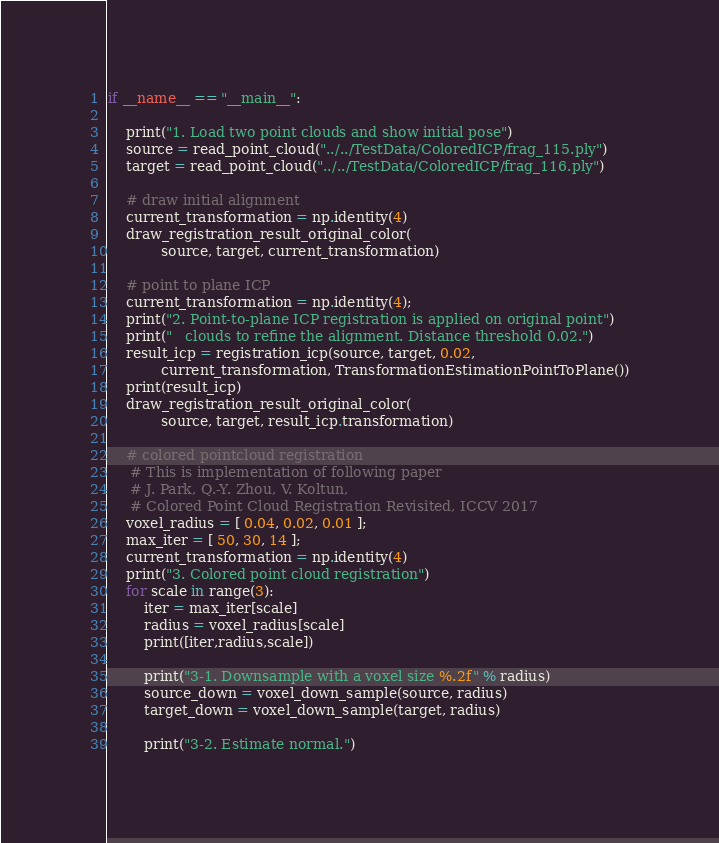<code> <loc_0><loc_0><loc_500><loc_500><_Python_>
if __name__ == "__main__":

    print("1. Load two point clouds and show initial pose")
    source = read_point_cloud("../../TestData/ColoredICP/frag_115.ply")
    target = read_point_cloud("../../TestData/ColoredICP/frag_116.ply")

    # draw initial alignment
    current_transformation = np.identity(4)
    draw_registration_result_original_color(
            source, target, current_transformation)

    # point to plane ICP
    current_transformation = np.identity(4);
    print("2. Point-to-plane ICP registration is applied on original point")
    print("   clouds to refine the alignment. Distance threshold 0.02.")
    result_icp = registration_icp(source, target, 0.02,
            current_transformation, TransformationEstimationPointToPlane())
    print(result_icp)
    draw_registration_result_original_color(
            source, target, result_icp.transformation)

    # colored pointcloud registration
     # This is implementation of following paper
     # J. Park, Q.-Y. Zhou, V. Koltun,
     # Colored Point Cloud Registration Revisited, ICCV 2017
    voxel_radius = [ 0.04, 0.02, 0.01 ];
    max_iter = [ 50, 30, 14 ];
    current_transformation = np.identity(4)
    print("3. Colored point cloud registration")
    for scale in range(3):
        iter = max_iter[scale]
        radius = voxel_radius[scale]
        print([iter,radius,scale])

        print("3-1. Downsample with a voxel size %.2f" % radius)
        source_down = voxel_down_sample(source, radius)
        target_down = voxel_down_sample(target, radius)

        print("3-2. Estimate normal.")</code> 